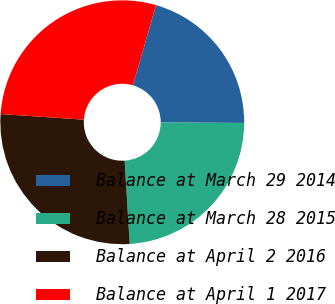Convert chart. <chart><loc_0><loc_0><loc_500><loc_500><pie_chart><fcel>Balance at March 29 2014<fcel>Balance at March 28 2015<fcel>Balance at April 2 2016<fcel>Balance at April 1 2017<nl><fcel>20.63%<fcel>23.94%<fcel>27.05%<fcel>28.39%<nl></chart> 